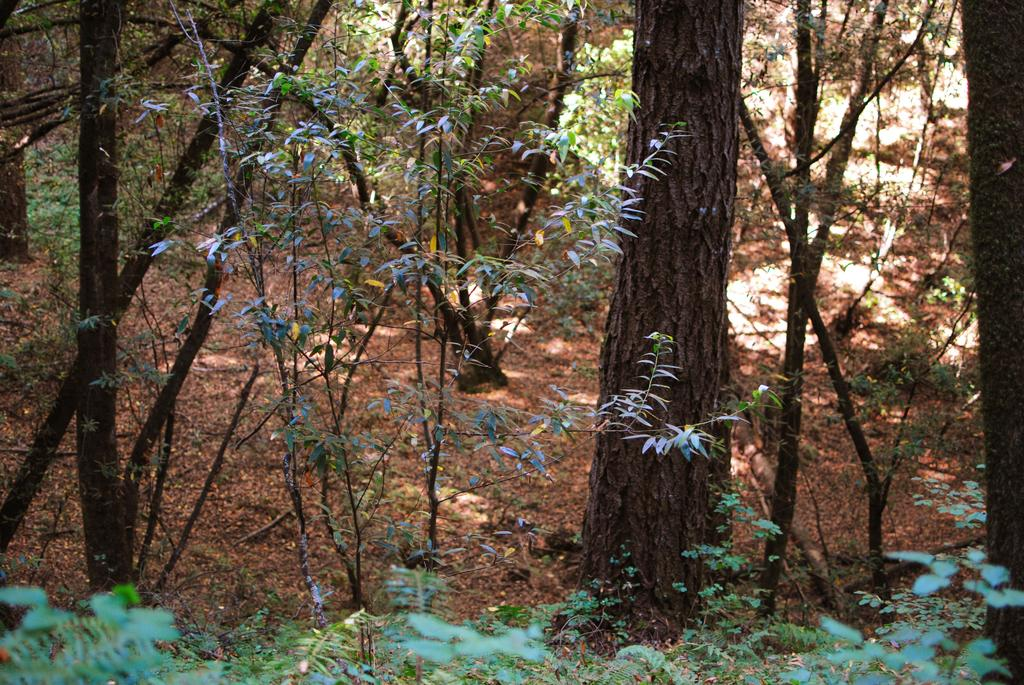What type of vegetation can be seen in the image? There are trees and plants in the image. Can you describe the specific types of plants in the image? The provided facts do not specify the types of plants, only that there are plants in the image. Reasoning: Let's think step by step by step in order to produce the conversation. We start by identifying the main subjects in the image, which are trees and plants. Then, we formulate questions that focus on the types of vegetation present in the image, ensuring that each question can be answered definitively with the information given. We avoid yes/no questions and ensure that the language is simple and clear. Absurd Question/Answer: What color is the paint on the hospital walls in the image? There is no hospital or paint present in the image; it only features trees and plants. What type of grain is being harvested in the image? There is no grain or harvesting activity present in the image; it only features trees and plants. 